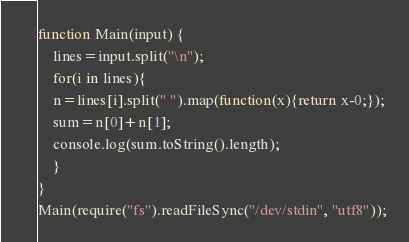Convert code to text. <code><loc_0><loc_0><loc_500><loc_500><_JavaScript_>function Main(input) {
    lines=input.split("\n");
    for(i in lines){
	n=lines[i].split(" ").map(function(x){return x-0;});
	sum=n[0]+n[1];
	console.log(sum.toString().length);
    }
}
Main(require("fs").readFileSync("/dev/stdin", "utf8"));</code> 